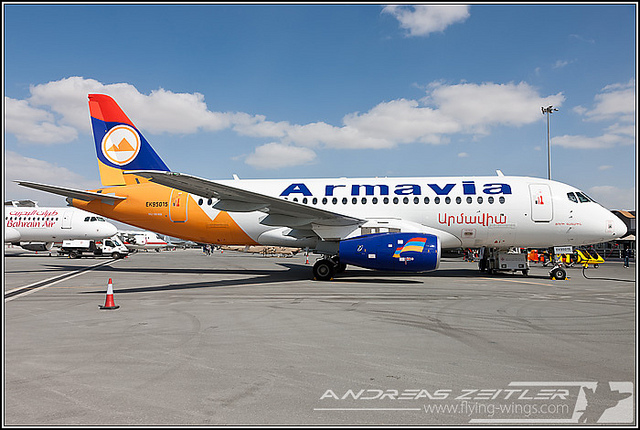Please identify all text content in this image. Armavia www.flying-wings.com ZEITLER ANDREAS 